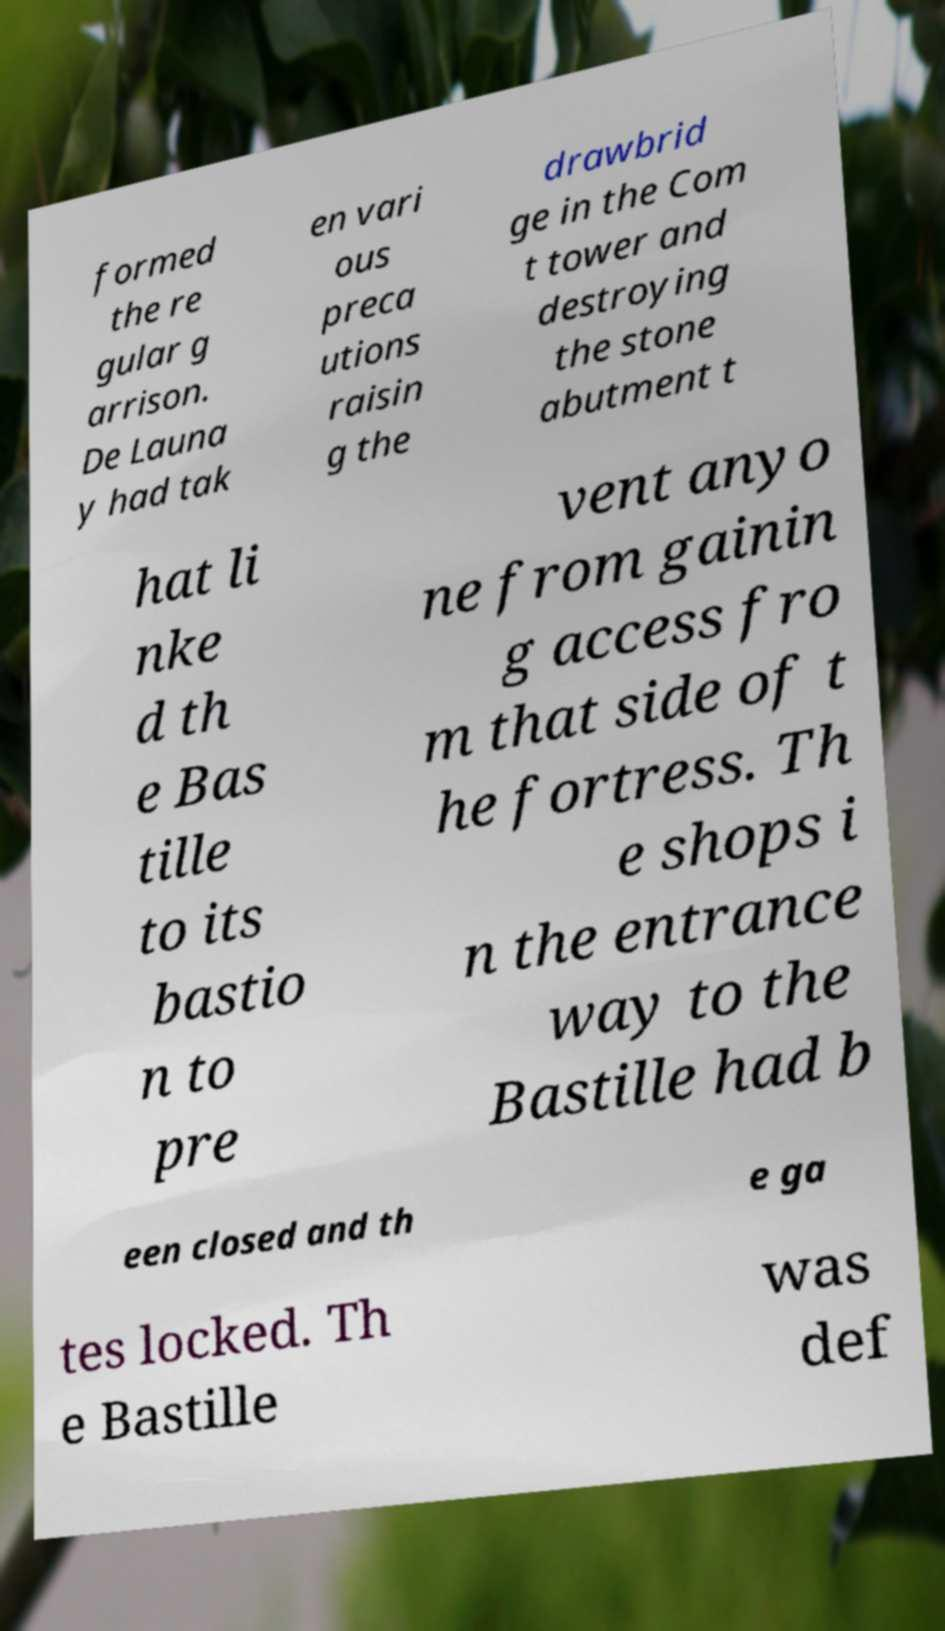Can you read and provide the text displayed in the image?This photo seems to have some interesting text. Can you extract and type it out for me? formed the re gular g arrison. De Launa y had tak en vari ous preca utions raisin g the drawbrid ge in the Com t tower and destroying the stone abutment t hat li nke d th e Bas tille to its bastio n to pre vent anyo ne from gainin g access fro m that side of t he fortress. Th e shops i n the entrance way to the Bastille had b een closed and th e ga tes locked. Th e Bastille was def 